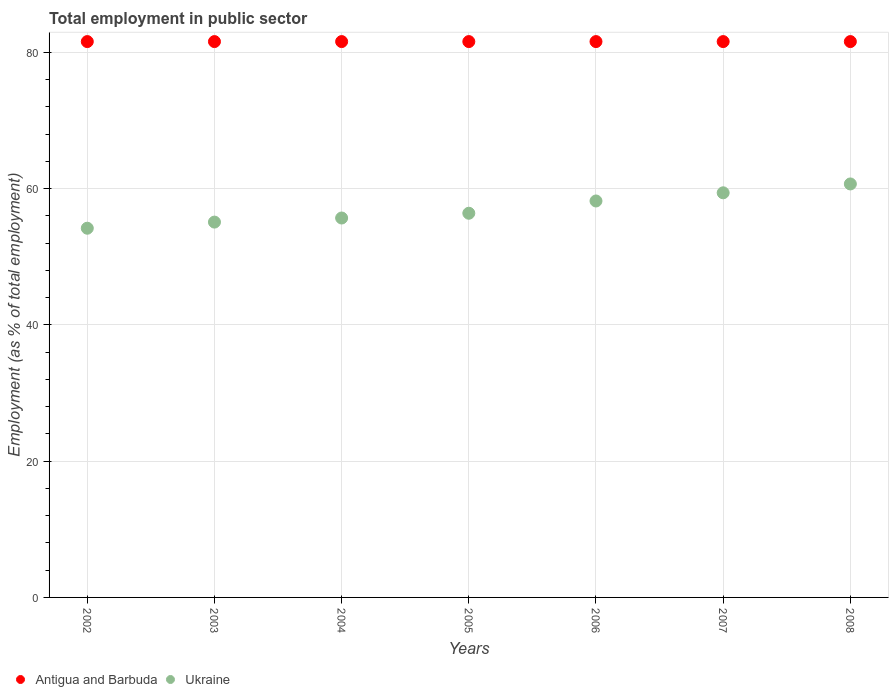Is the number of dotlines equal to the number of legend labels?
Ensure brevity in your answer.  Yes. What is the employment in public sector in Antigua and Barbuda in 2007?
Your response must be concise. 81.6. Across all years, what is the maximum employment in public sector in Ukraine?
Your response must be concise. 60.7. Across all years, what is the minimum employment in public sector in Ukraine?
Make the answer very short. 54.2. In which year was the employment in public sector in Antigua and Barbuda maximum?
Provide a short and direct response. 2002. In which year was the employment in public sector in Antigua and Barbuda minimum?
Offer a terse response. 2002. What is the total employment in public sector in Antigua and Barbuda in the graph?
Ensure brevity in your answer.  571.2. What is the difference between the employment in public sector in Ukraine in 2005 and the employment in public sector in Antigua and Barbuda in 2008?
Provide a succinct answer. -25.2. What is the average employment in public sector in Ukraine per year?
Your answer should be compact. 57.1. In the year 2004, what is the difference between the employment in public sector in Antigua and Barbuda and employment in public sector in Ukraine?
Provide a short and direct response. 25.9. In how many years, is the employment in public sector in Ukraine greater than 44 %?
Keep it short and to the point. 7. What is the ratio of the employment in public sector in Antigua and Barbuda in 2002 to that in 2003?
Keep it short and to the point. 1. Is the employment in public sector in Antigua and Barbuda in 2002 less than that in 2007?
Give a very brief answer. No. What is the difference between the highest and the lowest employment in public sector in Ukraine?
Provide a succinct answer. 6.5. Is the sum of the employment in public sector in Antigua and Barbuda in 2003 and 2005 greater than the maximum employment in public sector in Ukraine across all years?
Offer a very short reply. Yes. Does the employment in public sector in Ukraine monotonically increase over the years?
Ensure brevity in your answer.  Yes. Is the employment in public sector in Ukraine strictly less than the employment in public sector in Antigua and Barbuda over the years?
Offer a terse response. Yes. How many years are there in the graph?
Give a very brief answer. 7. What is the difference between two consecutive major ticks on the Y-axis?
Offer a terse response. 20. How many legend labels are there?
Provide a short and direct response. 2. What is the title of the graph?
Provide a short and direct response. Total employment in public sector. What is the label or title of the X-axis?
Provide a short and direct response. Years. What is the label or title of the Y-axis?
Keep it short and to the point. Employment (as % of total employment). What is the Employment (as % of total employment) in Antigua and Barbuda in 2002?
Your response must be concise. 81.6. What is the Employment (as % of total employment) in Ukraine in 2002?
Make the answer very short. 54.2. What is the Employment (as % of total employment) in Antigua and Barbuda in 2003?
Ensure brevity in your answer.  81.6. What is the Employment (as % of total employment) in Ukraine in 2003?
Offer a very short reply. 55.1. What is the Employment (as % of total employment) in Antigua and Barbuda in 2004?
Provide a succinct answer. 81.6. What is the Employment (as % of total employment) of Ukraine in 2004?
Make the answer very short. 55.7. What is the Employment (as % of total employment) in Antigua and Barbuda in 2005?
Offer a very short reply. 81.6. What is the Employment (as % of total employment) in Ukraine in 2005?
Offer a terse response. 56.4. What is the Employment (as % of total employment) of Antigua and Barbuda in 2006?
Offer a very short reply. 81.6. What is the Employment (as % of total employment) of Ukraine in 2006?
Give a very brief answer. 58.2. What is the Employment (as % of total employment) in Antigua and Barbuda in 2007?
Make the answer very short. 81.6. What is the Employment (as % of total employment) in Ukraine in 2007?
Your answer should be very brief. 59.4. What is the Employment (as % of total employment) in Antigua and Barbuda in 2008?
Keep it short and to the point. 81.6. What is the Employment (as % of total employment) of Ukraine in 2008?
Ensure brevity in your answer.  60.7. Across all years, what is the maximum Employment (as % of total employment) of Antigua and Barbuda?
Make the answer very short. 81.6. Across all years, what is the maximum Employment (as % of total employment) in Ukraine?
Provide a succinct answer. 60.7. Across all years, what is the minimum Employment (as % of total employment) in Antigua and Barbuda?
Your response must be concise. 81.6. Across all years, what is the minimum Employment (as % of total employment) in Ukraine?
Your response must be concise. 54.2. What is the total Employment (as % of total employment) in Antigua and Barbuda in the graph?
Provide a short and direct response. 571.2. What is the total Employment (as % of total employment) in Ukraine in the graph?
Your response must be concise. 399.7. What is the difference between the Employment (as % of total employment) of Antigua and Barbuda in 2002 and that in 2003?
Your answer should be compact. 0. What is the difference between the Employment (as % of total employment) of Antigua and Barbuda in 2002 and that in 2004?
Offer a very short reply. 0. What is the difference between the Employment (as % of total employment) of Antigua and Barbuda in 2002 and that in 2006?
Give a very brief answer. 0. What is the difference between the Employment (as % of total employment) in Ukraine in 2002 and that in 2006?
Your response must be concise. -4. What is the difference between the Employment (as % of total employment) in Antigua and Barbuda in 2003 and that in 2004?
Your answer should be compact. 0. What is the difference between the Employment (as % of total employment) of Ukraine in 2003 and that in 2004?
Give a very brief answer. -0.6. What is the difference between the Employment (as % of total employment) of Antigua and Barbuda in 2003 and that in 2005?
Your answer should be very brief. 0. What is the difference between the Employment (as % of total employment) in Ukraine in 2003 and that in 2005?
Your answer should be very brief. -1.3. What is the difference between the Employment (as % of total employment) of Antigua and Barbuda in 2003 and that in 2007?
Give a very brief answer. 0. What is the difference between the Employment (as % of total employment) of Ukraine in 2003 and that in 2008?
Your response must be concise. -5.6. What is the difference between the Employment (as % of total employment) of Ukraine in 2004 and that in 2005?
Make the answer very short. -0.7. What is the difference between the Employment (as % of total employment) of Ukraine in 2004 and that in 2007?
Keep it short and to the point. -3.7. What is the difference between the Employment (as % of total employment) in Antigua and Barbuda in 2004 and that in 2008?
Make the answer very short. 0. What is the difference between the Employment (as % of total employment) of Ukraine in 2004 and that in 2008?
Your answer should be compact. -5. What is the difference between the Employment (as % of total employment) in Ukraine in 2005 and that in 2007?
Your answer should be very brief. -3. What is the difference between the Employment (as % of total employment) in Ukraine in 2006 and that in 2008?
Keep it short and to the point. -2.5. What is the difference between the Employment (as % of total employment) of Antigua and Barbuda in 2007 and that in 2008?
Provide a succinct answer. 0. What is the difference between the Employment (as % of total employment) of Ukraine in 2007 and that in 2008?
Ensure brevity in your answer.  -1.3. What is the difference between the Employment (as % of total employment) in Antigua and Barbuda in 2002 and the Employment (as % of total employment) in Ukraine in 2003?
Ensure brevity in your answer.  26.5. What is the difference between the Employment (as % of total employment) in Antigua and Barbuda in 2002 and the Employment (as % of total employment) in Ukraine in 2004?
Make the answer very short. 25.9. What is the difference between the Employment (as % of total employment) in Antigua and Barbuda in 2002 and the Employment (as % of total employment) in Ukraine in 2005?
Ensure brevity in your answer.  25.2. What is the difference between the Employment (as % of total employment) in Antigua and Barbuda in 2002 and the Employment (as % of total employment) in Ukraine in 2006?
Provide a succinct answer. 23.4. What is the difference between the Employment (as % of total employment) in Antigua and Barbuda in 2002 and the Employment (as % of total employment) in Ukraine in 2007?
Your response must be concise. 22.2. What is the difference between the Employment (as % of total employment) in Antigua and Barbuda in 2002 and the Employment (as % of total employment) in Ukraine in 2008?
Ensure brevity in your answer.  20.9. What is the difference between the Employment (as % of total employment) of Antigua and Barbuda in 2003 and the Employment (as % of total employment) of Ukraine in 2004?
Provide a short and direct response. 25.9. What is the difference between the Employment (as % of total employment) in Antigua and Barbuda in 2003 and the Employment (as % of total employment) in Ukraine in 2005?
Your answer should be compact. 25.2. What is the difference between the Employment (as % of total employment) of Antigua and Barbuda in 2003 and the Employment (as % of total employment) of Ukraine in 2006?
Ensure brevity in your answer.  23.4. What is the difference between the Employment (as % of total employment) of Antigua and Barbuda in 2003 and the Employment (as % of total employment) of Ukraine in 2008?
Your answer should be compact. 20.9. What is the difference between the Employment (as % of total employment) of Antigua and Barbuda in 2004 and the Employment (as % of total employment) of Ukraine in 2005?
Your answer should be compact. 25.2. What is the difference between the Employment (as % of total employment) in Antigua and Barbuda in 2004 and the Employment (as % of total employment) in Ukraine in 2006?
Provide a short and direct response. 23.4. What is the difference between the Employment (as % of total employment) in Antigua and Barbuda in 2004 and the Employment (as % of total employment) in Ukraine in 2007?
Your answer should be compact. 22.2. What is the difference between the Employment (as % of total employment) of Antigua and Barbuda in 2004 and the Employment (as % of total employment) of Ukraine in 2008?
Offer a terse response. 20.9. What is the difference between the Employment (as % of total employment) in Antigua and Barbuda in 2005 and the Employment (as % of total employment) in Ukraine in 2006?
Your response must be concise. 23.4. What is the difference between the Employment (as % of total employment) in Antigua and Barbuda in 2005 and the Employment (as % of total employment) in Ukraine in 2007?
Offer a terse response. 22.2. What is the difference between the Employment (as % of total employment) of Antigua and Barbuda in 2005 and the Employment (as % of total employment) of Ukraine in 2008?
Your answer should be compact. 20.9. What is the difference between the Employment (as % of total employment) in Antigua and Barbuda in 2006 and the Employment (as % of total employment) in Ukraine in 2008?
Your answer should be very brief. 20.9. What is the difference between the Employment (as % of total employment) in Antigua and Barbuda in 2007 and the Employment (as % of total employment) in Ukraine in 2008?
Make the answer very short. 20.9. What is the average Employment (as % of total employment) in Antigua and Barbuda per year?
Ensure brevity in your answer.  81.6. What is the average Employment (as % of total employment) in Ukraine per year?
Offer a very short reply. 57.1. In the year 2002, what is the difference between the Employment (as % of total employment) of Antigua and Barbuda and Employment (as % of total employment) of Ukraine?
Offer a very short reply. 27.4. In the year 2003, what is the difference between the Employment (as % of total employment) in Antigua and Barbuda and Employment (as % of total employment) in Ukraine?
Ensure brevity in your answer.  26.5. In the year 2004, what is the difference between the Employment (as % of total employment) in Antigua and Barbuda and Employment (as % of total employment) in Ukraine?
Provide a short and direct response. 25.9. In the year 2005, what is the difference between the Employment (as % of total employment) in Antigua and Barbuda and Employment (as % of total employment) in Ukraine?
Make the answer very short. 25.2. In the year 2006, what is the difference between the Employment (as % of total employment) of Antigua and Barbuda and Employment (as % of total employment) of Ukraine?
Provide a succinct answer. 23.4. In the year 2008, what is the difference between the Employment (as % of total employment) in Antigua and Barbuda and Employment (as % of total employment) in Ukraine?
Your answer should be very brief. 20.9. What is the ratio of the Employment (as % of total employment) of Antigua and Barbuda in 2002 to that in 2003?
Keep it short and to the point. 1. What is the ratio of the Employment (as % of total employment) of Ukraine in 2002 to that in 2003?
Your answer should be very brief. 0.98. What is the ratio of the Employment (as % of total employment) of Ukraine in 2002 to that in 2004?
Your answer should be compact. 0.97. What is the ratio of the Employment (as % of total employment) in Antigua and Barbuda in 2002 to that in 2005?
Offer a very short reply. 1. What is the ratio of the Employment (as % of total employment) of Ukraine in 2002 to that in 2005?
Ensure brevity in your answer.  0.96. What is the ratio of the Employment (as % of total employment) in Ukraine in 2002 to that in 2006?
Offer a terse response. 0.93. What is the ratio of the Employment (as % of total employment) in Antigua and Barbuda in 2002 to that in 2007?
Ensure brevity in your answer.  1. What is the ratio of the Employment (as % of total employment) in Ukraine in 2002 to that in 2007?
Keep it short and to the point. 0.91. What is the ratio of the Employment (as % of total employment) in Antigua and Barbuda in 2002 to that in 2008?
Make the answer very short. 1. What is the ratio of the Employment (as % of total employment) of Ukraine in 2002 to that in 2008?
Provide a short and direct response. 0.89. What is the ratio of the Employment (as % of total employment) of Antigua and Barbuda in 2003 to that in 2004?
Offer a terse response. 1. What is the ratio of the Employment (as % of total employment) of Antigua and Barbuda in 2003 to that in 2005?
Provide a short and direct response. 1. What is the ratio of the Employment (as % of total employment) in Ukraine in 2003 to that in 2005?
Ensure brevity in your answer.  0.98. What is the ratio of the Employment (as % of total employment) in Ukraine in 2003 to that in 2006?
Provide a short and direct response. 0.95. What is the ratio of the Employment (as % of total employment) in Ukraine in 2003 to that in 2007?
Your response must be concise. 0.93. What is the ratio of the Employment (as % of total employment) in Antigua and Barbuda in 2003 to that in 2008?
Provide a succinct answer. 1. What is the ratio of the Employment (as % of total employment) in Ukraine in 2003 to that in 2008?
Keep it short and to the point. 0.91. What is the ratio of the Employment (as % of total employment) of Antigua and Barbuda in 2004 to that in 2005?
Your response must be concise. 1. What is the ratio of the Employment (as % of total employment) of Ukraine in 2004 to that in 2005?
Your answer should be compact. 0.99. What is the ratio of the Employment (as % of total employment) in Ukraine in 2004 to that in 2006?
Your response must be concise. 0.96. What is the ratio of the Employment (as % of total employment) of Ukraine in 2004 to that in 2007?
Keep it short and to the point. 0.94. What is the ratio of the Employment (as % of total employment) in Ukraine in 2004 to that in 2008?
Ensure brevity in your answer.  0.92. What is the ratio of the Employment (as % of total employment) in Antigua and Barbuda in 2005 to that in 2006?
Make the answer very short. 1. What is the ratio of the Employment (as % of total employment) in Ukraine in 2005 to that in 2006?
Offer a terse response. 0.97. What is the ratio of the Employment (as % of total employment) of Ukraine in 2005 to that in 2007?
Give a very brief answer. 0.95. What is the ratio of the Employment (as % of total employment) of Ukraine in 2005 to that in 2008?
Your response must be concise. 0.93. What is the ratio of the Employment (as % of total employment) in Antigua and Barbuda in 2006 to that in 2007?
Provide a short and direct response. 1. What is the ratio of the Employment (as % of total employment) of Ukraine in 2006 to that in 2007?
Give a very brief answer. 0.98. What is the ratio of the Employment (as % of total employment) in Ukraine in 2006 to that in 2008?
Provide a succinct answer. 0.96. What is the ratio of the Employment (as % of total employment) of Ukraine in 2007 to that in 2008?
Your response must be concise. 0.98. What is the difference between the highest and the second highest Employment (as % of total employment) of Antigua and Barbuda?
Your answer should be very brief. 0. 